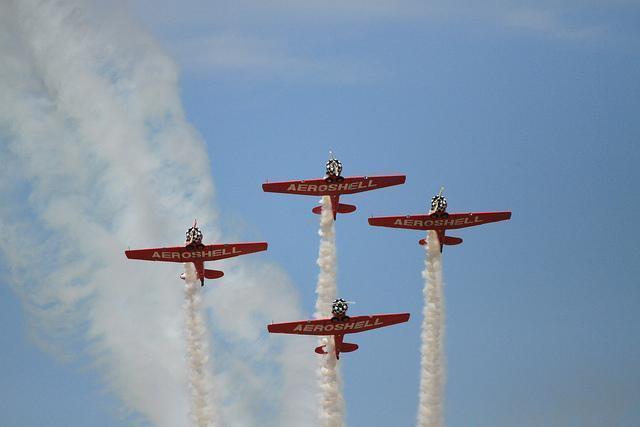What are these planes emitting?
From the following four choices, select the correct answer to address the question.
Options: Balloons, foam, pesticides, contrails. Contrails. 